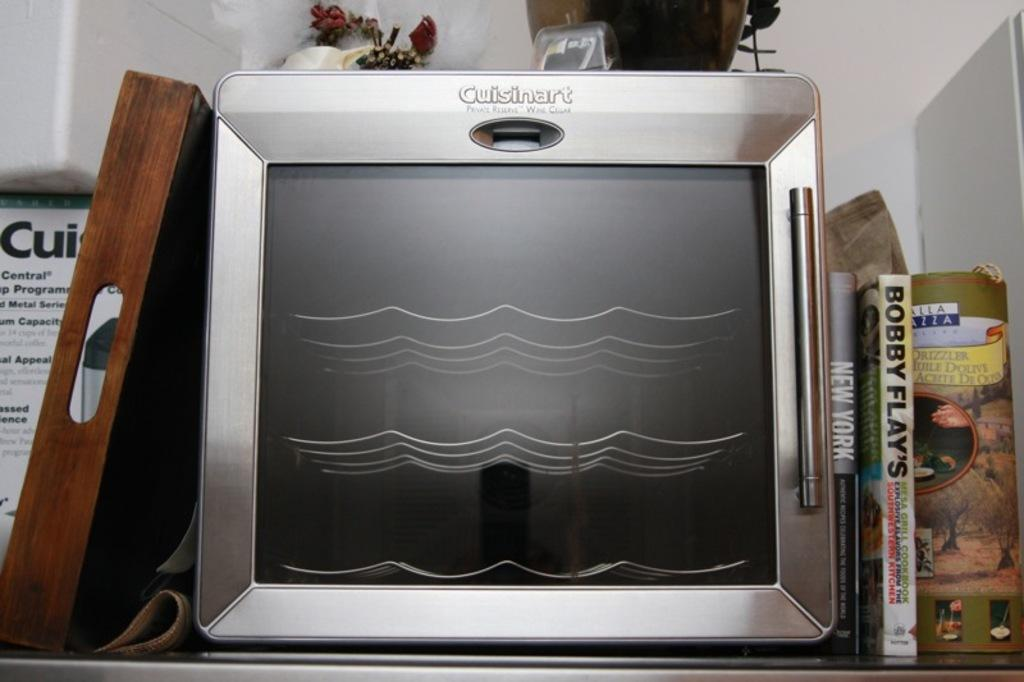<image>
Create a compact narrative representing the image presented. A stainless steel Cuisinart wine cooler is on a shelf. 